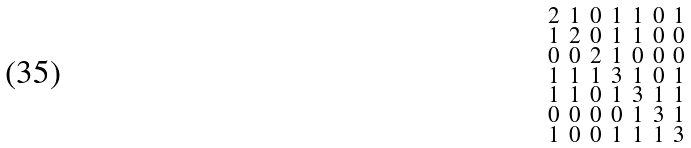<formula> <loc_0><loc_0><loc_500><loc_500>\begin{smallmatrix} 2 & 1 & 0 & 1 & 1 & 0 & 1 \\ 1 & 2 & 0 & 1 & 1 & 0 & 0 \\ 0 & 0 & 2 & 1 & 0 & 0 & 0 \\ 1 & 1 & 1 & 3 & 1 & 0 & 1 \\ 1 & 1 & 0 & 1 & 3 & 1 & 1 \\ 0 & 0 & 0 & 0 & 1 & 3 & 1 \\ 1 & 0 & 0 & 1 & 1 & 1 & 3 \end{smallmatrix}</formula> 